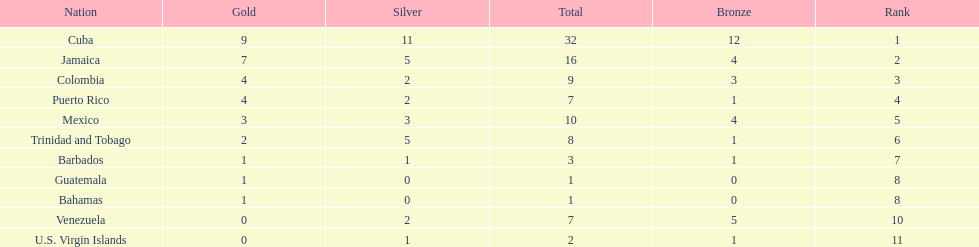Nations that had 10 or more medals each Cuba, Jamaica, Mexico. 